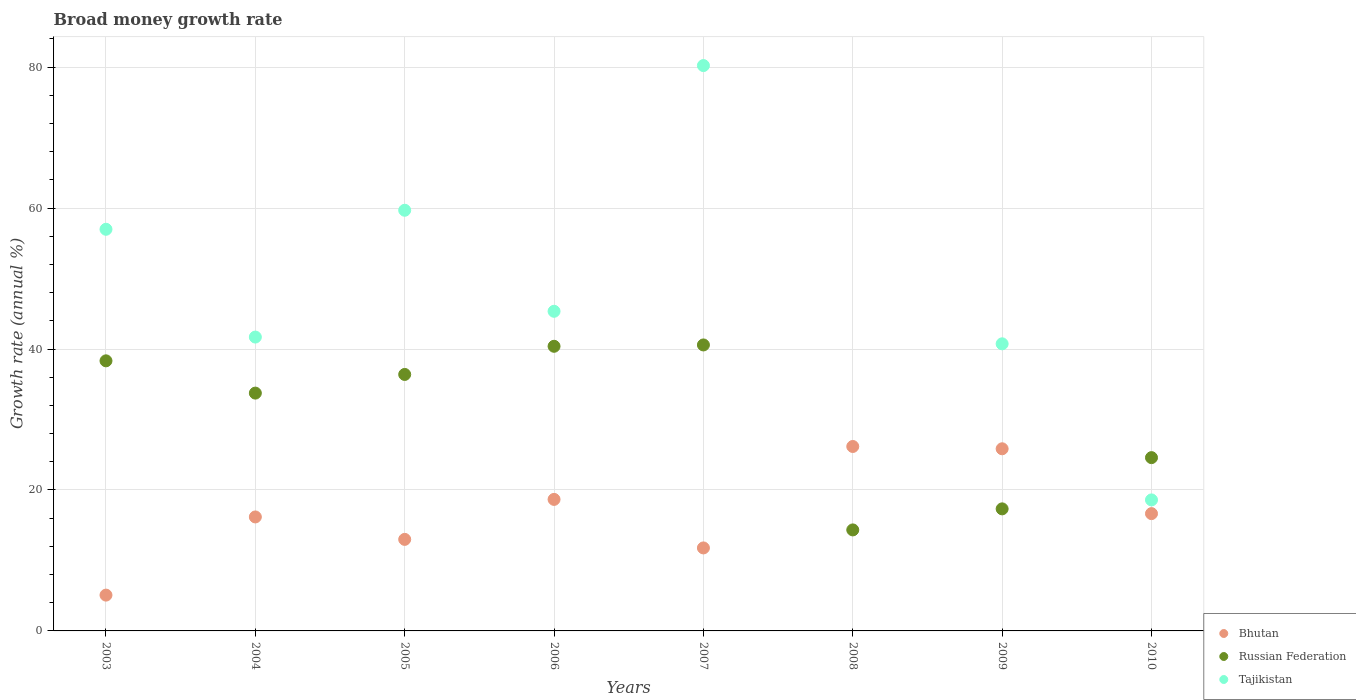How many different coloured dotlines are there?
Offer a very short reply. 3. What is the growth rate in Bhutan in 2003?
Your answer should be very brief. 5.08. Across all years, what is the maximum growth rate in Bhutan?
Your answer should be very brief. 26.17. Across all years, what is the minimum growth rate in Russian Federation?
Offer a terse response. 14.33. What is the total growth rate in Tajikistan in the graph?
Your answer should be very brief. 343.28. What is the difference between the growth rate in Tajikistan in 2009 and that in 2010?
Ensure brevity in your answer.  22.15. What is the difference between the growth rate in Tajikistan in 2004 and the growth rate in Bhutan in 2005?
Your answer should be compact. 28.71. What is the average growth rate in Russian Federation per year?
Offer a terse response. 30.71. In the year 2004, what is the difference between the growth rate in Bhutan and growth rate in Tajikistan?
Your answer should be compact. -25.52. What is the ratio of the growth rate in Russian Federation in 2006 to that in 2010?
Your answer should be very brief. 1.64. Is the difference between the growth rate in Bhutan in 2007 and 2009 greater than the difference between the growth rate in Tajikistan in 2007 and 2009?
Offer a very short reply. No. What is the difference between the highest and the second highest growth rate in Russian Federation?
Give a very brief answer. 0.19. What is the difference between the highest and the lowest growth rate in Russian Federation?
Ensure brevity in your answer.  26.25. In how many years, is the growth rate in Tajikistan greater than the average growth rate in Tajikistan taken over all years?
Offer a very short reply. 4. Is the sum of the growth rate in Russian Federation in 2007 and 2008 greater than the maximum growth rate in Bhutan across all years?
Offer a terse response. Yes. Is it the case that in every year, the sum of the growth rate in Bhutan and growth rate in Tajikistan  is greater than the growth rate in Russian Federation?
Provide a short and direct response. Yes. Does the growth rate in Tajikistan monotonically increase over the years?
Offer a very short reply. No. How many years are there in the graph?
Your answer should be compact. 8. What is the difference between two consecutive major ticks on the Y-axis?
Your answer should be very brief. 20. Does the graph contain any zero values?
Give a very brief answer. Yes. Does the graph contain grids?
Your answer should be compact. Yes. How many legend labels are there?
Provide a succinct answer. 3. How are the legend labels stacked?
Your response must be concise. Vertical. What is the title of the graph?
Offer a terse response. Broad money growth rate. Does "Cote d'Ivoire" appear as one of the legend labels in the graph?
Ensure brevity in your answer.  No. What is the label or title of the Y-axis?
Your answer should be very brief. Growth rate (annual %). What is the Growth rate (annual %) in Bhutan in 2003?
Provide a succinct answer. 5.08. What is the Growth rate (annual %) in Russian Federation in 2003?
Make the answer very short. 38.33. What is the Growth rate (annual %) in Tajikistan in 2003?
Make the answer very short. 56.99. What is the Growth rate (annual %) in Bhutan in 2004?
Provide a succinct answer. 16.17. What is the Growth rate (annual %) of Russian Federation in 2004?
Provide a short and direct response. 33.75. What is the Growth rate (annual %) of Tajikistan in 2004?
Give a very brief answer. 41.7. What is the Growth rate (annual %) in Bhutan in 2005?
Offer a very short reply. 12.99. What is the Growth rate (annual %) of Russian Federation in 2005?
Your answer should be compact. 36.39. What is the Growth rate (annual %) in Tajikistan in 2005?
Your response must be concise. 59.69. What is the Growth rate (annual %) of Bhutan in 2006?
Give a very brief answer. 18.66. What is the Growth rate (annual %) of Russian Federation in 2006?
Keep it short and to the point. 40.39. What is the Growth rate (annual %) of Tajikistan in 2006?
Provide a short and direct response. 45.35. What is the Growth rate (annual %) in Bhutan in 2007?
Your answer should be very brief. 11.78. What is the Growth rate (annual %) in Russian Federation in 2007?
Make the answer very short. 40.58. What is the Growth rate (annual %) of Tajikistan in 2007?
Offer a terse response. 80.22. What is the Growth rate (annual %) in Bhutan in 2008?
Your answer should be very brief. 26.17. What is the Growth rate (annual %) of Russian Federation in 2008?
Your response must be concise. 14.33. What is the Growth rate (annual %) of Bhutan in 2009?
Your response must be concise. 25.84. What is the Growth rate (annual %) in Russian Federation in 2009?
Your response must be concise. 17.32. What is the Growth rate (annual %) in Tajikistan in 2009?
Keep it short and to the point. 40.74. What is the Growth rate (annual %) in Bhutan in 2010?
Keep it short and to the point. 16.64. What is the Growth rate (annual %) in Russian Federation in 2010?
Provide a succinct answer. 24.59. What is the Growth rate (annual %) in Tajikistan in 2010?
Your answer should be compact. 18.59. Across all years, what is the maximum Growth rate (annual %) of Bhutan?
Keep it short and to the point. 26.17. Across all years, what is the maximum Growth rate (annual %) in Russian Federation?
Your response must be concise. 40.58. Across all years, what is the maximum Growth rate (annual %) in Tajikistan?
Give a very brief answer. 80.22. Across all years, what is the minimum Growth rate (annual %) in Bhutan?
Your response must be concise. 5.08. Across all years, what is the minimum Growth rate (annual %) of Russian Federation?
Make the answer very short. 14.33. Across all years, what is the minimum Growth rate (annual %) in Tajikistan?
Ensure brevity in your answer.  0. What is the total Growth rate (annual %) of Bhutan in the graph?
Offer a very short reply. 133.34. What is the total Growth rate (annual %) in Russian Federation in the graph?
Your answer should be compact. 245.67. What is the total Growth rate (annual %) in Tajikistan in the graph?
Provide a short and direct response. 343.28. What is the difference between the Growth rate (annual %) of Bhutan in 2003 and that in 2004?
Ensure brevity in your answer.  -11.09. What is the difference between the Growth rate (annual %) of Russian Federation in 2003 and that in 2004?
Offer a terse response. 4.58. What is the difference between the Growth rate (annual %) of Tajikistan in 2003 and that in 2004?
Your answer should be very brief. 15.29. What is the difference between the Growth rate (annual %) of Bhutan in 2003 and that in 2005?
Your answer should be compact. -7.91. What is the difference between the Growth rate (annual %) in Russian Federation in 2003 and that in 2005?
Your response must be concise. 1.93. What is the difference between the Growth rate (annual %) of Tajikistan in 2003 and that in 2005?
Provide a succinct answer. -2.7. What is the difference between the Growth rate (annual %) of Bhutan in 2003 and that in 2006?
Provide a short and direct response. -13.58. What is the difference between the Growth rate (annual %) of Russian Federation in 2003 and that in 2006?
Your answer should be very brief. -2.06. What is the difference between the Growth rate (annual %) of Tajikistan in 2003 and that in 2006?
Offer a terse response. 11.64. What is the difference between the Growth rate (annual %) of Bhutan in 2003 and that in 2007?
Provide a succinct answer. -6.69. What is the difference between the Growth rate (annual %) in Russian Federation in 2003 and that in 2007?
Ensure brevity in your answer.  -2.25. What is the difference between the Growth rate (annual %) of Tajikistan in 2003 and that in 2007?
Your response must be concise. -23.23. What is the difference between the Growth rate (annual %) in Bhutan in 2003 and that in 2008?
Your answer should be very brief. -21.09. What is the difference between the Growth rate (annual %) of Russian Federation in 2003 and that in 2008?
Provide a short and direct response. 23.99. What is the difference between the Growth rate (annual %) of Bhutan in 2003 and that in 2009?
Your answer should be very brief. -20.76. What is the difference between the Growth rate (annual %) of Russian Federation in 2003 and that in 2009?
Give a very brief answer. 21.01. What is the difference between the Growth rate (annual %) of Tajikistan in 2003 and that in 2009?
Your answer should be compact. 16.25. What is the difference between the Growth rate (annual %) in Bhutan in 2003 and that in 2010?
Offer a very short reply. -11.56. What is the difference between the Growth rate (annual %) in Russian Federation in 2003 and that in 2010?
Provide a short and direct response. 13.74. What is the difference between the Growth rate (annual %) in Tajikistan in 2003 and that in 2010?
Offer a very short reply. 38.4. What is the difference between the Growth rate (annual %) of Bhutan in 2004 and that in 2005?
Your answer should be very brief. 3.18. What is the difference between the Growth rate (annual %) of Russian Federation in 2004 and that in 2005?
Give a very brief answer. -2.65. What is the difference between the Growth rate (annual %) of Tajikistan in 2004 and that in 2005?
Make the answer very short. -17.99. What is the difference between the Growth rate (annual %) in Bhutan in 2004 and that in 2006?
Your answer should be very brief. -2.49. What is the difference between the Growth rate (annual %) of Russian Federation in 2004 and that in 2006?
Ensure brevity in your answer.  -6.64. What is the difference between the Growth rate (annual %) of Tajikistan in 2004 and that in 2006?
Your response must be concise. -3.66. What is the difference between the Growth rate (annual %) in Bhutan in 2004 and that in 2007?
Offer a terse response. 4.4. What is the difference between the Growth rate (annual %) in Russian Federation in 2004 and that in 2007?
Provide a short and direct response. -6.83. What is the difference between the Growth rate (annual %) in Tajikistan in 2004 and that in 2007?
Offer a terse response. -38.52. What is the difference between the Growth rate (annual %) in Bhutan in 2004 and that in 2008?
Offer a very short reply. -10. What is the difference between the Growth rate (annual %) in Russian Federation in 2004 and that in 2008?
Provide a short and direct response. 19.41. What is the difference between the Growth rate (annual %) in Bhutan in 2004 and that in 2009?
Provide a succinct answer. -9.67. What is the difference between the Growth rate (annual %) in Russian Federation in 2004 and that in 2009?
Provide a succinct answer. 16.43. What is the difference between the Growth rate (annual %) in Tajikistan in 2004 and that in 2009?
Your response must be concise. 0.96. What is the difference between the Growth rate (annual %) of Bhutan in 2004 and that in 2010?
Offer a very short reply. -0.47. What is the difference between the Growth rate (annual %) of Russian Federation in 2004 and that in 2010?
Make the answer very short. 9.16. What is the difference between the Growth rate (annual %) of Tajikistan in 2004 and that in 2010?
Offer a terse response. 23.11. What is the difference between the Growth rate (annual %) of Bhutan in 2005 and that in 2006?
Your answer should be very brief. -5.67. What is the difference between the Growth rate (annual %) in Russian Federation in 2005 and that in 2006?
Your answer should be compact. -4. What is the difference between the Growth rate (annual %) in Tajikistan in 2005 and that in 2006?
Give a very brief answer. 14.34. What is the difference between the Growth rate (annual %) in Bhutan in 2005 and that in 2007?
Your answer should be very brief. 1.21. What is the difference between the Growth rate (annual %) of Russian Federation in 2005 and that in 2007?
Ensure brevity in your answer.  -4.19. What is the difference between the Growth rate (annual %) in Tajikistan in 2005 and that in 2007?
Your answer should be compact. -20.53. What is the difference between the Growth rate (annual %) in Bhutan in 2005 and that in 2008?
Make the answer very short. -13.18. What is the difference between the Growth rate (annual %) in Russian Federation in 2005 and that in 2008?
Give a very brief answer. 22.06. What is the difference between the Growth rate (annual %) in Bhutan in 2005 and that in 2009?
Offer a very short reply. -12.86. What is the difference between the Growth rate (annual %) of Russian Federation in 2005 and that in 2009?
Ensure brevity in your answer.  19.07. What is the difference between the Growth rate (annual %) of Tajikistan in 2005 and that in 2009?
Your answer should be very brief. 18.95. What is the difference between the Growth rate (annual %) of Bhutan in 2005 and that in 2010?
Your answer should be compact. -3.65. What is the difference between the Growth rate (annual %) of Russian Federation in 2005 and that in 2010?
Provide a short and direct response. 11.8. What is the difference between the Growth rate (annual %) of Tajikistan in 2005 and that in 2010?
Your answer should be compact. 41.1. What is the difference between the Growth rate (annual %) of Bhutan in 2006 and that in 2007?
Offer a terse response. 6.89. What is the difference between the Growth rate (annual %) in Russian Federation in 2006 and that in 2007?
Your answer should be very brief. -0.19. What is the difference between the Growth rate (annual %) of Tajikistan in 2006 and that in 2007?
Offer a very short reply. -34.87. What is the difference between the Growth rate (annual %) of Bhutan in 2006 and that in 2008?
Give a very brief answer. -7.51. What is the difference between the Growth rate (annual %) of Russian Federation in 2006 and that in 2008?
Provide a succinct answer. 26.06. What is the difference between the Growth rate (annual %) in Bhutan in 2006 and that in 2009?
Your response must be concise. -7.18. What is the difference between the Growth rate (annual %) in Russian Federation in 2006 and that in 2009?
Offer a very short reply. 23.07. What is the difference between the Growth rate (annual %) of Tajikistan in 2006 and that in 2009?
Your answer should be compact. 4.62. What is the difference between the Growth rate (annual %) in Bhutan in 2006 and that in 2010?
Give a very brief answer. 2.02. What is the difference between the Growth rate (annual %) of Russian Federation in 2006 and that in 2010?
Your answer should be very brief. 15.8. What is the difference between the Growth rate (annual %) of Tajikistan in 2006 and that in 2010?
Keep it short and to the point. 26.77. What is the difference between the Growth rate (annual %) of Bhutan in 2007 and that in 2008?
Provide a succinct answer. -14.4. What is the difference between the Growth rate (annual %) in Russian Federation in 2007 and that in 2008?
Your answer should be very brief. 26.25. What is the difference between the Growth rate (annual %) of Bhutan in 2007 and that in 2009?
Ensure brevity in your answer.  -14.07. What is the difference between the Growth rate (annual %) in Russian Federation in 2007 and that in 2009?
Your response must be concise. 23.26. What is the difference between the Growth rate (annual %) in Tajikistan in 2007 and that in 2009?
Provide a short and direct response. 39.48. What is the difference between the Growth rate (annual %) in Bhutan in 2007 and that in 2010?
Your response must be concise. -4.87. What is the difference between the Growth rate (annual %) in Russian Federation in 2007 and that in 2010?
Your response must be concise. 15.99. What is the difference between the Growth rate (annual %) in Tajikistan in 2007 and that in 2010?
Give a very brief answer. 61.63. What is the difference between the Growth rate (annual %) in Bhutan in 2008 and that in 2009?
Provide a short and direct response. 0.33. What is the difference between the Growth rate (annual %) of Russian Federation in 2008 and that in 2009?
Your response must be concise. -2.99. What is the difference between the Growth rate (annual %) of Bhutan in 2008 and that in 2010?
Offer a terse response. 9.53. What is the difference between the Growth rate (annual %) in Russian Federation in 2008 and that in 2010?
Make the answer very short. -10.26. What is the difference between the Growth rate (annual %) in Bhutan in 2009 and that in 2010?
Your answer should be compact. 9.2. What is the difference between the Growth rate (annual %) of Russian Federation in 2009 and that in 2010?
Ensure brevity in your answer.  -7.27. What is the difference between the Growth rate (annual %) of Tajikistan in 2009 and that in 2010?
Provide a succinct answer. 22.15. What is the difference between the Growth rate (annual %) of Bhutan in 2003 and the Growth rate (annual %) of Russian Federation in 2004?
Your answer should be very brief. -28.66. What is the difference between the Growth rate (annual %) in Bhutan in 2003 and the Growth rate (annual %) in Tajikistan in 2004?
Your answer should be compact. -36.62. What is the difference between the Growth rate (annual %) of Russian Federation in 2003 and the Growth rate (annual %) of Tajikistan in 2004?
Provide a short and direct response. -3.37. What is the difference between the Growth rate (annual %) in Bhutan in 2003 and the Growth rate (annual %) in Russian Federation in 2005?
Provide a short and direct response. -31.31. What is the difference between the Growth rate (annual %) of Bhutan in 2003 and the Growth rate (annual %) of Tajikistan in 2005?
Your response must be concise. -54.61. What is the difference between the Growth rate (annual %) of Russian Federation in 2003 and the Growth rate (annual %) of Tajikistan in 2005?
Give a very brief answer. -21.37. What is the difference between the Growth rate (annual %) in Bhutan in 2003 and the Growth rate (annual %) in Russian Federation in 2006?
Ensure brevity in your answer.  -35.31. What is the difference between the Growth rate (annual %) in Bhutan in 2003 and the Growth rate (annual %) in Tajikistan in 2006?
Keep it short and to the point. -40.27. What is the difference between the Growth rate (annual %) in Russian Federation in 2003 and the Growth rate (annual %) in Tajikistan in 2006?
Offer a very short reply. -7.03. What is the difference between the Growth rate (annual %) in Bhutan in 2003 and the Growth rate (annual %) in Russian Federation in 2007?
Your response must be concise. -35.5. What is the difference between the Growth rate (annual %) in Bhutan in 2003 and the Growth rate (annual %) in Tajikistan in 2007?
Offer a terse response. -75.14. What is the difference between the Growth rate (annual %) in Russian Federation in 2003 and the Growth rate (annual %) in Tajikistan in 2007?
Ensure brevity in your answer.  -41.9. What is the difference between the Growth rate (annual %) in Bhutan in 2003 and the Growth rate (annual %) in Russian Federation in 2008?
Your answer should be compact. -9.25. What is the difference between the Growth rate (annual %) of Bhutan in 2003 and the Growth rate (annual %) of Russian Federation in 2009?
Offer a very short reply. -12.24. What is the difference between the Growth rate (annual %) in Bhutan in 2003 and the Growth rate (annual %) in Tajikistan in 2009?
Offer a terse response. -35.66. What is the difference between the Growth rate (annual %) of Russian Federation in 2003 and the Growth rate (annual %) of Tajikistan in 2009?
Your response must be concise. -2.41. What is the difference between the Growth rate (annual %) in Bhutan in 2003 and the Growth rate (annual %) in Russian Federation in 2010?
Keep it short and to the point. -19.51. What is the difference between the Growth rate (annual %) in Bhutan in 2003 and the Growth rate (annual %) in Tajikistan in 2010?
Your answer should be very brief. -13.51. What is the difference between the Growth rate (annual %) in Russian Federation in 2003 and the Growth rate (annual %) in Tajikistan in 2010?
Offer a very short reply. 19.74. What is the difference between the Growth rate (annual %) in Bhutan in 2004 and the Growth rate (annual %) in Russian Federation in 2005?
Your answer should be very brief. -20.22. What is the difference between the Growth rate (annual %) in Bhutan in 2004 and the Growth rate (annual %) in Tajikistan in 2005?
Offer a very short reply. -43.52. What is the difference between the Growth rate (annual %) of Russian Federation in 2004 and the Growth rate (annual %) of Tajikistan in 2005?
Provide a succinct answer. -25.94. What is the difference between the Growth rate (annual %) of Bhutan in 2004 and the Growth rate (annual %) of Russian Federation in 2006?
Keep it short and to the point. -24.22. What is the difference between the Growth rate (annual %) in Bhutan in 2004 and the Growth rate (annual %) in Tajikistan in 2006?
Make the answer very short. -29.18. What is the difference between the Growth rate (annual %) in Russian Federation in 2004 and the Growth rate (annual %) in Tajikistan in 2006?
Your response must be concise. -11.61. What is the difference between the Growth rate (annual %) of Bhutan in 2004 and the Growth rate (annual %) of Russian Federation in 2007?
Offer a very short reply. -24.41. What is the difference between the Growth rate (annual %) of Bhutan in 2004 and the Growth rate (annual %) of Tajikistan in 2007?
Keep it short and to the point. -64.05. What is the difference between the Growth rate (annual %) of Russian Federation in 2004 and the Growth rate (annual %) of Tajikistan in 2007?
Your answer should be very brief. -46.48. What is the difference between the Growth rate (annual %) of Bhutan in 2004 and the Growth rate (annual %) of Russian Federation in 2008?
Provide a succinct answer. 1.84. What is the difference between the Growth rate (annual %) of Bhutan in 2004 and the Growth rate (annual %) of Russian Federation in 2009?
Ensure brevity in your answer.  -1.15. What is the difference between the Growth rate (annual %) of Bhutan in 2004 and the Growth rate (annual %) of Tajikistan in 2009?
Ensure brevity in your answer.  -24.57. What is the difference between the Growth rate (annual %) in Russian Federation in 2004 and the Growth rate (annual %) in Tajikistan in 2009?
Provide a short and direct response. -6.99. What is the difference between the Growth rate (annual %) in Bhutan in 2004 and the Growth rate (annual %) in Russian Federation in 2010?
Offer a very short reply. -8.42. What is the difference between the Growth rate (annual %) of Bhutan in 2004 and the Growth rate (annual %) of Tajikistan in 2010?
Your answer should be very brief. -2.42. What is the difference between the Growth rate (annual %) of Russian Federation in 2004 and the Growth rate (annual %) of Tajikistan in 2010?
Make the answer very short. 15.16. What is the difference between the Growth rate (annual %) in Bhutan in 2005 and the Growth rate (annual %) in Russian Federation in 2006?
Your answer should be compact. -27.4. What is the difference between the Growth rate (annual %) of Bhutan in 2005 and the Growth rate (annual %) of Tajikistan in 2006?
Provide a short and direct response. -32.37. What is the difference between the Growth rate (annual %) in Russian Federation in 2005 and the Growth rate (annual %) in Tajikistan in 2006?
Your response must be concise. -8.96. What is the difference between the Growth rate (annual %) in Bhutan in 2005 and the Growth rate (annual %) in Russian Federation in 2007?
Your answer should be compact. -27.59. What is the difference between the Growth rate (annual %) of Bhutan in 2005 and the Growth rate (annual %) of Tajikistan in 2007?
Your answer should be compact. -67.23. What is the difference between the Growth rate (annual %) of Russian Federation in 2005 and the Growth rate (annual %) of Tajikistan in 2007?
Your response must be concise. -43.83. What is the difference between the Growth rate (annual %) of Bhutan in 2005 and the Growth rate (annual %) of Russian Federation in 2008?
Ensure brevity in your answer.  -1.34. What is the difference between the Growth rate (annual %) of Bhutan in 2005 and the Growth rate (annual %) of Russian Federation in 2009?
Your response must be concise. -4.33. What is the difference between the Growth rate (annual %) in Bhutan in 2005 and the Growth rate (annual %) in Tajikistan in 2009?
Your answer should be very brief. -27.75. What is the difference between the Growth rate (annual %) of Russian Federation in 2005 and the Growth rate (annual %) of Tajikistan in 2009?
Make the answer very short. -4.35. What is the difference between the Growth rate (annual %) in Bhutan in 2005 and the Growth rate (annual %) in Russian Federation in 2010?
Give a very brief answer. -11.6. What is the difference between the Growth rate (annual %) of Bhutan in 2005 and the Growth rate (annual %) of Tajikistan in 2010?
Make the answer very short. -5.6. What is the difference between the Growth rate (annual %) in Russian Federation in 2005 and the Growth rate (annual %) in Tajikistan in 2010?
Ensure brevity in your answer.  17.8. What is the difference between the Growth rate (annual %) in Bhutan in 2006 and the Growth rate (annual %) in Russian Federation in 2007?
Your answer should be very brief. -21.92. What is the difference between the Growth rate (annual %) in Bhutan in 2006 and the Growth rate (annual %) in Tajikistan in 2007?
Provide a short and direct response. -61.56. What is the difference between the Growth rate (annual %) in Russian Federation in 2006 and the Growth rate (annual %) in Tajikistan in 2007?
Your answer should be compact. -39.83. What is the difference between the Growth rate (annual %) of Bhutan in 2006 and the Growth rate (annual %) of Russian Federation in 2008?
Your answer should be very brief. 4.33. What is the difference between the Growth rate (annual %) in Bhutan in 2006 and the Growth rate (annual %) in Russian Federation in 2009?
Offer a very short reply. 1.34. What is the difference between the Growth rate (annual %) in Bhutan in 2006 and the Growth rate (annual %) in Tajikistan in 2009?
Keep it short and to the point. -22.08. What is the difference between the Growth rate (annual %) in Russian Federation in 2006 and the Growth rate (annual %) in Tajikistan in 2009?
Offer a very short reply. -0.35. What is the difference between the Growth rate (annual %) of Bhutan in 2006 and the Growth rate (annual %) of Russian Federation in 2010?
Offer a terse response. -5.93. What is the difference between the Growth rate (annual %) in Bhutan in 2006 and the Growth rate (annual %) in Tajikistan in 2010?
Offer a very short reply. 0.07. What is the difference between the Growth rate (annual %) of Russian Federation in 2006 and the Growth rate (annual %) of Tajikistan in 2010?
Provide a succinct answer. 21.8. What is the difference between the Growth rate (annual %) in Bhutan in 2007 and the Growth rate (annual %) in Russian Federation in 2008?
Provide a short and direct response. -2.56. What is the difference between the Growth rate (annual %) in Bhutan in 2007 and the Growth rate (annual %) in Russian Federation in 2009?
Your response must be concise. -5.54. What is the difference between the Growth rate (annual %) in Bhutan in 2007 and the Growth rate (annual %) in Tajikistan in 2009?
Your response must be concise. -28.96. What is the difference between the Growth rate (annual %) of Russian Federation in 2007 and the Growth rate (annual %) of Tajikistan in 2009?
Give a very brief answer. -0.16. What is the difference between the Growth rate (annual %) of Bhutan in 2007 and the Growth rate (annual %) of Russian Federation in 2010?
Offer a very short reply. -12.81. What is the difference between the Growth rate (annual %) in Bhutan in 2007 and the Growth rate (annual %) in Tajikistan in 2010?
Your answer should be very brief. -6.81. What is the difference between the Growth rate (annual %) in Russian Federation in 2007 and the Growth rate (annual %) in Tajikistan in 2010?
Ensure brevity in your answer.  21.99. What is the difference between the Growth rate (annual %) in Bhutan in 2008 and the Growth rate (annual %) in Russian Federation in 2009?
Provide a short and direct response. 8.85. What is the difference between the Growth rate (annual %) in Bhutan in 2008 and the Growth rate (annual %) in Tajikistan in 2009?
Give a very brief answer. -14.57. What is the difference between the Growth rate (annual %) of Russian Federation in 2008 and the Growth rate (annual %) of Tajikistan in 2009?
Your answer should be very brief. -26.41. What is the difference between the Growth rate (annual %) of Bhutan in 2008 and the Growth rate (annual %) of Russian Federation in 2010?
Ensure brevity in your answer.  1.58. What is the difference between the Growth rate (annual %) in Bhutan in 2008 and the Growth rate (annual %) in Tajikistan in 2010?
Your answer should be compact. 7.58. What is the difference between the Growth rate (annual %) in Russian Federation in 2008 and the Growth rate (annual %) in Tajikistan in 2010?
Provide a short and direct response. -4.26. What is the difference between the Growth rate (annual %) in Bhutan in 2009 and the Growth rate (annual %) in Russian Federation in 2010?
Your response must be concise. 1.26. What is the difference between the Growth rate (annual %) of Bhutan in 2009 and the Growth rate (annual %) of Tajikistan in 2010?
Offer a terse response. 7.26. What is the difference between the Growth rate (annual %) of Russian Federation in 2009 and the Growth rate (annual %) of Tajikistan in 2010?
Your answer should be very brief. -1.27. What is the average Growth rate (annual %) in Bhutan per year?
Your answer should be very brief. 16.67. What is the average Growth rate (annual %) in Russian Federation per year?
Provide a succinct answer. 30.71. What is the average Growth rate (annual %) of Tajikistan per year?
Provide a short and direct response. 42.91. In the year 2003, what is the difference between the Growth rate (annual %) in Bhutan and Growth rate (annual %) in Russian Federation?
Provide a short and direct response. -33.24. In the year 2003, what is the difference between the Growth rate (annual %) of Bhutan and Growth rate (annual %) of Tajikistan?
Offer a terse response. -51.91. In the year 2003, what is the difference between the Growth rate (annual %) in Russian Federation and Growth rate (annual %) in Tajikistan?
Keep it short and to the point. -18.67. In the year 2004, what is the difference between the Growth rate (annual %) of Bhutan and Growth rate (annual %) of Russian Federation?
Your response must be concise. -17.57. In the year 2004, what is the difference between the Growth rate (annual %) in Bhutan and Growth rate (annual %) in Tajikistan?
Keep it short and to the point. -25.52. In the year 2004, what is the difference between the Growth rate (annual %) of Russian Federation and Growth rate (annual %) of Tajikistan?
Keep it short and to the point. -7.95. In the year 2005, what is the difference between the Growth rate (annual %) of Bhutan and Growth rate (annual %) of Russian Federation?
Provide a succinct answer. -23.4. In the year 2005, what is the difference between the Growth rate (annual %) of Bhutan and Growth rate (annual %) of Tajikistan?
Your answer should be very brief. -46.7. In the year 2005, what is the difference between the Growth rate (annual %) of Russian Federation and Growth rate (annual %) of Tajikistan?
Your answer should be compact. -23.3. In the year 2006, what is the difference between the Growth rate (annual %) of Bhutan and Growth rate (annual %) of Russian Federation?
Offer a terse response. -21.73. In the year 2006, what is the difference between the Growth rate (annual %) in Bhutan and Growth rate (annual %) in Tajikistan?
Provide a succinct answer. -26.69. In the year 2006, what is the difference between the Growth rate (annual %) of Russian Federation and Growth rate (annual %) of Tajikistan?
Your answer should be compact. -4.97. In the year 2007, what is the difference between the Growth rate (annual %) of Bhutan and Growth rate (annual %) of Russian Federation?
Give a very brief answer. -28.8. In the year 2007, what is the difference between the Growth rate (annual %) of Bhutan and Growth rate (annual %) of Tajikistan?
Offer a very short reply. -68.45. In the year 2007, what is the difference between the Growth rate (annual %) in Russian Federation and Growth rate (annual %) in Tajikistan?
Provide a short and direct response. -39.64. In the year 2008, what is the difference between the Growth rate (annual %) of Bhutan and Growth rate (annual %) of Russian Federation?
Your answer should be compact. 11.84. In the year 2009, what is the difference between the Growth rate (annual %) in Bhutan and Growth rate (annual %) in Russian Federation?
Ensure brevity in your answer.  8.52. In the year 2009, what is the difference between the Growth rate (annual %) in Bhutan and Growth rate (annual %) in Tajikistan?
Your answer should be compact. -14.89. In the year 2009, what is the difference between the Growth rate (annual %) of Russian Federation and Growth rate (annual %) of Tajikistan?
Your answer should be very brief. -23.42. In the year 2010, what is the difference between the Growth rate (annual %) in Bhutan and Growth rate (annual %) in Russian Federation?
Your answer should be compact. -7.94. In the year 2010, what is the difference between the Growth rate (annual %) in Bhutan and Growth rate (annual %) in Tajikistan?
Provide a succinct answer. -1.95. In the year 2010, what is the difference between the Growth rate (annual %) of Russian Federation and Growth rate (annual %) of Tajikistan?
Your answer should be very brief. 6. What is the ratio of the Growth rate (annual %) in Bhutan in 2003 to that in 2004?
Make the answer very short. 0.31. What is the ratio of the Growth rate (annual %) of Russian Federation in 2003 to that in 2004?
Make the answer very short. 1.14. What is the ratio of the Growth rate (annual %) of Tajikistan in 2003 to that in 2004?
Keep it short and to the point. 1.37. What is the ratio of the Growth rate (annual %) in Bhutan in 2003 to that in 2005?
Make the answer very short. 0.39. What is the ratio of the Growth rate (annual %) of Russian Federation in 2003 to that in 2005?
Give a very brief answer. 1.05. What is the ratio of the Growth rate (annual %) in Tajikistan in 2003 to that in 2005?
Provide a succinct answer. 0.95. What is the ratio of the Growth rate (annual %) of Bhutan in 2003 to that in 2006?
Offer a terse response. 0.27. What is the ratio of the Growth rate (annual %) of Russian Federation in 2003 to that in 2006?
Offer a very short reply. 0.95. What is the ratio of the Growth rate (annual %) in Tajikistan in 2003 to that in 2006?
Provide a succinct answer. 1.26. What is the ratio of the Growth rate (annual %) of Bhutan in 2003 to that in 2007?
Offer a very short reply. 0.43. What is the ratio of the Growth rate (annual %) in Tajikistan in 2003 to that in 2007?
Offer a terse response. 0.71. What is the ratio of the Growth rate (annual %) of Bhutan in 2003 to that in 2008?
Provide a short and direct response. 0.19. What is the ratio of the Growth rate (annual %) of Russian Federation in 2003 to that in 2008?
Keep it short and to the point. 2.67. What is the ratio of the Growth rate (annual %) of Bhutan in 2003 to that in 2009?
Your answer should be compact. 0.2. What is the ratio of the Growth rate (annual %) in Russian Federation in 2003 to that in 2009?
Give a very brief answer. 2.21. What is the ratio of the Growth rate (annual %) of Tajikistan in 2003 to that in 2009?
Make the answer very short. 1.4. What is the ratio of the Growth rate (annual %) in Bhutan in 2003 to that in 2010?
Keep it short and to the point. 0.31. What is the ratio of the Growth rate (annual %) of Russian Federation in 2003 to that in 2010?
Make the answer very short. 1.56. What is the ratio of the Growth rate (annual %) in Tajikistan in 2003 to that in 2010?
Keep it short and to the point. 3.07. What is the ratio of the Growth rate (annual %) in Bhutan in 2004 to that in 2005?
Your answer should be very brief. 1.25. What is the ratio of the Growth rate (annual %) of Russian Federation in 2004 to that in 2005?
Provide a succinct answer. 0.93. What is the ratio of the Growth rate (annual %) in Tajikistan in 2004 to that in 2005?
Provide a succinct answer. 0.7. What is the ratio of the Growth rate (annual %) in Bhutan in 2004 to that in 2006?
Your answer should be compact. 0.87. What is the ratio of the Growth rate (annual %) of Russian Federation in 2004 to that in 2006?
Offer a very short reply. 0.84. What is the ratio of the Growth rate (annual %) in Tajikistan in 2004 to that in 2006?
Ensure brevity in your answer.  0.92. What is the ratio of the Growth rate (annual %) in Bhutan in 2004 to that in 2007?
Provide a succinct answer. 1.37. What is the ratio of the Growth rate (annual %) of Russian Federation in 2004 to that in 2007?
Offer a terse response. 0.83. What is the ratio of the Growth rate (annual %) of Tajikistan in 2004 to that in 2007?
Offer a very short reply. 0.52. What is the ratio of the Growth rate (annual %) in Bhutan in 2004 to that in 2008?
Keep it short and to the point. 0.62. What is the ratio of the Growth rate (annual %) of Russian Federation in 2004 to that in 2008?
Provide a short and direct response. 2.35. What is the ratio of the Growth rate (annual %) of Bhutan in 2004 to that in 2009?
Keep it short and to the point. 0.63. What is the ratio of the Growth rate (annual %) of Russian Federation in 2004 to that in 2009?
Make the answer very short. 1.95. What is the ratio of the Growth rate (annual %) in Tajikistan in 2004 to that in 2009?
Offer a very short reply. 1.02. What is the ratio of the Growth rate (annual %) of Bhutan in 2004 to that in 2010?
Keep it short and to the point. 0.97. What is the ratio of the Growth rate (annual %) of Russian Federation in 2004 to that in 2010?
Your answer should be compact. 1.37. What is the ratio of the Growth rate (annual %) of Tajikistan in 2004 to that in 2010?
Give a very brief answer. 2.24. What is the ratio of the Growth rate (annual %) in Bhutan in 2005 to that in 2006?
Provide a short and direct response. 0.7. What is the ratio of the Growth rate (annual %) of Russian Federation in 2005 to that in 2006?
Make the answer very short. 0.9. What is the ratio of the Growth rate (annual %) in Tajikistan in 2005 to that in 2006?
Your answer should be compact. 1.32. What is the ratio of the Growth rate (annual %) of Bhutan in 2005 to that in 2007?
Give a very brief answer. 1.1. What is the ratio of the Growth rate (annual %) in Russian Federation in 2005 to that in 2007?
Offer a terse response. 0.9. What is the ratio of the Growth rate (annual %) of Tajikistan in 2005 to that in 2007?
Offer a very short reply. 0.74. What is the ratio of the Growth rate (annual %) of Bhutan in 2005 to that in 2008?
Your response must be concise. 0.5. What is the ratio of the Growth rate (annual %) in Russian Federation in 2005 to that in 2008?
Give a very brief answer. 2.54. What is the ratio of the Growth rate (annual %) of Bhutan in 2005 to that in 2009?
Keep it short and to the point. 0.5. What is the ratio of the Growth rate (annual %) in Russian Federation in 2005 to that in 2009?
Make the answer very short. 2.1. What is the ratio of the Growth rate (annual %) of Tajikistan in 2005 to that in 2009?
Your response must be concise. 1.47. What is the ratio of the Growth rate (annual %) of Bhutan in 2005 to that in 2010?
Keep it short and to the point. 0.78. What is the ratio of the Growth rate (annual %) of Russian Federation in 2005 to that in 2010?
Provide a succinct answer. 1.48. What is the ratio of the Growth rate (annual %) of Tajikistan in 2005 to that in 2010?
Your answer should be compact. 3.21. What is the ratio of the Growth rate (annual %) of Bhutan in 2006 to that in 2007?
Give a very brief answer. 1.58. What is the ratio of the Growth rate (annual %) of Russian Federation in 2006 to that in 2007?
Ensure brevity in your answer.  1. What is the ratio of the Growth rate (annual %) of Tajikistan in 2006 to that in 2007?
Provide a succinct answer. 0.57. What is the ratio of the Growth rate (annual %) of Bhutan in 2006 to that in 2008?
Your response must be concise. 0.71. What is the ratio of the Growth rate (annual %) of Russian Federation in 2006 to that in 2008?
Make the answer very short. 2.82. What is the ratio of the Growth rate (annual %) of Bhutan in 2006 to that in 2009?
Offer a terse response. 0.72. What is the ratio of the Growth rate (annual %) in Russian Federation in 2006 to that in 2009?
Your answer should be very brief. 2.33. What is the ratio of the Growth rate (annual %) of Tajikistan in 2006 to that in 2009?
Ensure brevity in your answer.  1.11. What is the ratio of the Growth rate (annual %) in Bhutan in 2006 to that in 2010?
Your response must be concise. 1.12. What is the ratio of the Growth rate (annual %) of Russian Federation in 2006 to that in 2010?
Your response must be concise. 1.64. What is the ratio of the Growth rate (annual %) of Tajikistan in 2006 to that in 2010?
Your answer should be very brief. 2.44. What is the ratio of the Growth rate (annual %) of Bhutan in 2007 to that in 2008?
Keep it short and to the point. 0.45. What is the ratio of the Growth rate (annual %) in Russian Federation in 2007 to that in 2008?
Offer a terse response. 2.83. What is the ratio of the Growth rate (annual %) in Bhutan in 2007 to that in 2009?
Offer a terse response. 0.46. What is the ratio of the Growth rate (annual %) in Russian Federation in 2007 to that in 2009?
Make the answer very short. 2.34. What is the ratio of the Growth rate (annual %) of Tajikistan in 2007 to that in 2009?
Offer a very short reply. 1.97. What is the ratio of the Growth rate (annual %) in Bhutan in 2007 to that in 2010?
Your response must be concise. 0.71. What is the ratio of the Growth rate (annual %) of Russian Federation in 2007 to that in 2010?
Provide a succinct answer. 1.65. What is the ratio of the Growth rate (annual %) in Tajikistan in 2007 to that in 2010?
Keep it short and to the point. 4.32. What is the ratio of the Growth rate (annual %) of Bhutan in 2008 to that in 2009?
Provide a succinct answer. 1.01. What is the ratio of the Growth rate (annual %) in Russian Federation in 2008 to that in 2009?
Provide a short and direct response. 0.83. What is the ratio of the Growth rate (annual %) in Bhutan in 2008 to that in 2010?
Your answer should be very brief. 1.57. What is the ratio of the Growth rate (annual %) of Russian Federation in 2008 to that in 2010?
Your answer should be compact. 0.58. What is the ratio of the Growth rate (annual %) in Bhutan in 2009 to that in 2010?
Provide a succinct answer. 1.55. What is the ratio of the Growth rate (annual %) in Russian Federation in 2009 to that in 2010?
Keep it short and to the point. 0.7. What is the ratio of the Growth rate (annual %) in Tajikistan in 2009 to that in 2010?
Your response must be concise. 2.19. What is the difference between the highest and the second highest Growth rate (annual %) of Bhutan?
Give a very brief answer. 0.33. What is the difference between the highest and the second highest Growth rate (annual %) in Russian Federation?
Provide a short and direct response. 0.19. What is the difference between the highest and the second highest Growth rate (annual %) of Tajikistan?
Offer a terse response. 20.53. What is the difference between the highest and the lowest Growth rate (annual %) of Bhutan?
Ensure brevity in your answer.  21.09. What is the difference between the highest and the lowest Growth rate (annual %) in Russian Federation?
Provide a short and direct response. 26.25. What is the difference between the highest and the lowest Growth rate (annual %) of Tajikistan?
Your answer should be compact. 80.22. 